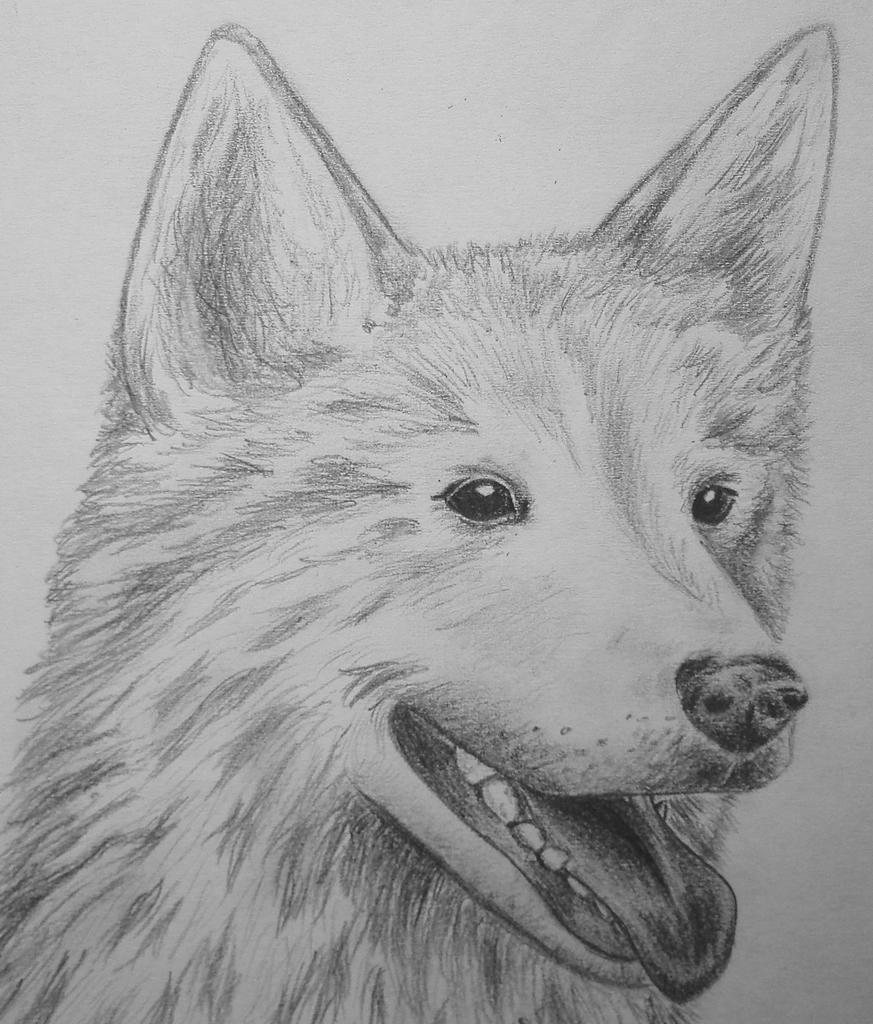How would you summarize this image in a sentence or two? In this image we can see a drawing of a dog. 